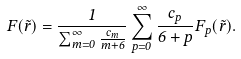Convert formula to latex. <formula><loc_0><loc_0><loc_500><loc_500>F ( \tilde { r } ) = \frac { 1 } { \sum _ { m = 0 } ^ { \infty } \frac { c _ { m } } { m + 6 } } \sum _ { p = 0 } ^ { \infty } \frac { c _ { p } } { 6 + p } F _ { p } ( \tilde { r } ) .</formula> 